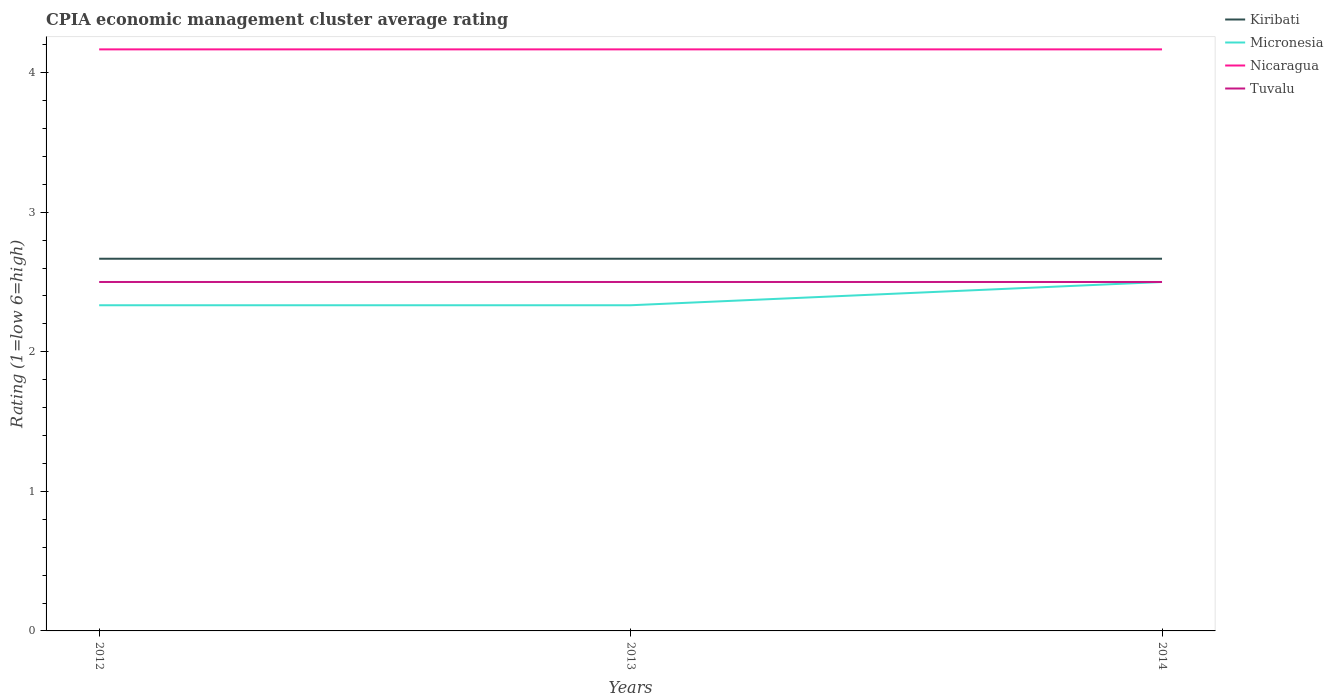Does the line corresponding to Nicaragua intersect with the line corresponding to Kiribati?
Give a very brief answer. No. Is the number of lines equal to the number of legend labels?
Keep it short and to the point. Yes. Across all years, what is the maximum CPIA rating in Micronesia?
Your response must be concise. 2.33. In which year was the CPIA rating in Nicaragua maximum?
Offer a terse response. 2012. What is the difference between the highest and the second highest CPIA rating in Kiribati?
Your answer should be very brief. 3.333333329802457e-6. What is the difference between the highest and the lowest CPIA rating in Tuvalu?
Provide a short and direct response. 0. Is the CPIA rating in Micronesia strictly greater than the CPIA rating in Tuvalu over the years?
Offer a terse response. No. How many years are there in the graph?
Provide a short and direct response. 3. What is the difference between two consecutive major ticks on the Y-axis?
Ensure brevity in your answer.  1. Are the values on the major ticks of Y-axis written in scientific E-notation?
Your answer should be very brief. No. Does the graph contain any zero values?
Make the answer very short. No. How are the legend labels stacked?
Your answer should be very brief. Vertical. What is the title of the graph?
Keep it short and to the point. CPIA economic management cluster average rating. Does "Qatar" appear as one of the legend labels in the graph?
Make the answer very short. No. What is the label or title of the X-axis?
Your answer should be compact. Years. What is the label or title of the Y-axis?
Provide a short and direct response. Rating (1=low 6=high). What is the Rating (1=low 6=high) of Kiribati in 2012?
Your answer should be compact. 2.67. What is the Rating (1=low 6=high) of Micronesia in 2012?
Ensure brevity in your answer.  2.33. What is the Rating (1=low 6=high) in Nicaragua in 2012?
Provide a succinct answer. 4.17. What is the Rating (1=low 6=high) of Tuvalu in 2012?
Offer a terse response. 2.5. What is the Rating (1=low 6=high) in Kiribati in 2013?
Give a very brief answer. 2.67. What is the Rating (1=low 6=high) in Micronesia in 2013?
Offer a very short reply. 2.33. What is the Rating (1=low 6=high) in Nicaragua in 2013?
Offer a terse response. 4.17. What is the Rating (1=low 6=high) of Tuvalu in 2013?
Your response must be concise. 2.5. What is the Rating (1=low 6=high) of Kiribati in 2014?
Make the answer very short. 2.67. What is the Rating (1=low 6=high) in Micronesia in 2014?
Provide a succinct answer. 2.5. What is the Rating (1=low 6=high) of Nicaragua in 2014?
Keep it short and to the point. 4.17. Across all years, what is the maximum Rating (1=low 6=high) in Kiribati?
Your response must be concise. 2.67. Across all years, what is the maximum Rating (1=low 6=high) in Micronesia?
Provide a succinct answer. 2.5. Across all years, what is the maximum Rating (1=low 6=high) in Nicaragua?
Provide a short and direct response. 4.17. Across all years, what is the maximum Rating (1=low 6=high) of Tuvalu?
Give a very brief answer. 2.5. Across all years, what is the minimum Rating (1=low 6=high) in Kiribati?
Your answer should be very brief. 2.67. Across all years, what is the minimum Rating (1=low 6=high) in Micronesia?
Your answer should be compact. 2.33. Across all years, what is the minimum Rating (1=low 6=high) in Nicaragua?
Your answer should be very brief. 4.17. What is the total Rating (1=low 6=high) in Micronesia in the graph?
Keep it short and to the point. 7.17. What is the total Rating (1=low 6=high) in Nicaragua in the graph?
Offer a very short reply. 12.5. What is the total Rating (1=low 6=high) in Tuvalu in the graph?
Your response must be concise. 7.5. What is the difference between the Rating (1=low 6=high) of Kiribati in 2012 and that in 2013?
Your answer should be compact. 0. What is the difference between the Rating (1=low 6=high) in Micronesia in 2012 and that in 2013?
Your response must be concise. 0. What is the difference between the Rating (1=low 6=high) in Nicaragua in 2012 and that in 2013?
Provide a succinct answer. 0. What is the difference between the Rating (1=low 6=high) of Micronesia in 2012 and that in 2014?
Give a very brief answer. -0.17. What is the difference between the Rating (1=low 6=high) of Tuvalu in 2012 and that in 2014?
Your answer should be very brief. 0. What is the difference between the Rating (1=low 6=high) in Micronesia in 2013 and that in 2014?
Provide a succinct answer. -0.17. What is the difference between the Rating (1=low 6=high) in Nicaragua in 2013 and that in 2014?
Make the answer very short. -0. What is the difference between the Rating (1=low 6=high) of Tuvalu in 2013 and that in 2014?
Provide a succinct answer. 0. What is the difference between the Rating (1=low 6=high) in Kiribati in 2012 and the Rating (1=low 6=high) in Nicaragua in 2013?
Offer a very short reply. -1.5. What is the difference between the Rating (1=low 6=high) of Kiribati in 2012 and the Rating (1=low 6=high) of Tuvalu in 2013?
Offer a very short reply. 0.17. What is the difference between the Rating (1=low 6=high) in Micronesia in 2012 and the Rating (1=low 6=high) in Nicaragua in 2013?
Offer a very short reply. -1.83. What is the difference between the Rating (1=low 6=high) in Micronesia in 2012 and the Rating (1=low 6=high) in Tuvalu in 2013?
Your answer should be very brief. -0.17. What is the difference between the Rating (1=low 6=high) of Nicaragua in 2012 and the Rating (1=low 6=high) of Tuvalu in 2013?
Provide a short and direct response. 1.67. What is the difference between the Rating (1=low 6=high) in Kiribati in 2012 and the Rating (1=low 6=high) in Micronesia in 2014?
Provide a succinct answer. 0.17. What is the difference between the Rating (1=low 6=high) of Kiribati in 2012 and the Rating (1=low 6=high) of Nicaragua in 2014?
Your response must be concise. -1.5. What is the difference between the Rating (1=low 6=high) of Kiribati in 2012 and the Rating (1=low 6=high) of Tuvalu in 2014?
Give a very brief answer. 0.17. What is the difference between the Rating (1=low 6=high) of Micronesia in 2012 and the Rating (1=low 6=high) of Nicaragua in 2014?
Offer a very short reply. -1.83. What is the difference between the Rating (1=low 6=high) in Kiribati in 2013 and the Rating (1=low 6=high) in Micronesia in 2014?
Make the answer very short. 0.17. What is the difference between the Rating (1=low 6=high) of Kiribati in 2013 and the Rating (1=low 6=high) of Nicaragua in 2014?
Offer a terse response. -1.5. What is the difference between the Rating (1=low 6=high) in Micronesia in 2013 and the Rating (1=low 6=high) in Nicaragua in 2014?
Your answer should be very brief. -1.83. What is the difference between the Rating (1=low 6=high) in Nicaragua in 2013 and the Rating (1=low 6=high) in Tuvalu in 2014?
Give a very brief answer. 1.67. What is the average Rating (1=low 6=high) in Kiribati per year?
Offer a terse response. 2.67. What is the average Rating (1=low 6=high) of Micronesia per year?
Offer a very short reply. 2.39. What is the average Rating (1=low 6=high) in Nicaragua per year?
Your response must be concise. 4.17. In the year 2012, what is the difference between the Rating (1=low 6=high) in Kiribati and Rating (1=low 6=high) in Tuvalu?
Make the answer very short. 0.17. In the year 2012, what is the difference between the Rating (1=low 6=high) of Micronesia and Rating (1=low 6=high) of Nicaragua?
Provide a succinct answer. -1.83. In the year 2012, what is the difference between the Rating (1=low 6=high) in Micronesia and Rating (1=low 6=high) in Tuvalu?
Offer a very short reply. -0.17. In the year 2013, what is the difference between the Rating (1=low 6=high) in Micronesia and Rating (1=low 6=high) in Nicaragua?
Make the answer very short. -1.83. In the year 2013, what is the difference between the Rating (1=low 6=high) in Nicaragua and Rating (1=low 6=high) in Tuvalu?
Offer a terse response. 1.67. In the year 2014, what is the difference between the Rating (1=low 6=high) of Kiribati and Rating (1=low 6=high) of Micronesia?
Make the answer very short. 0.17. In the year 2014, what is the difference between the Rating (1=low 6=high) in Kiribati and Rating (1=low 6=high) in Nicaragua?
Give a very brief answer. -1.5. In the year 2014, what is the difference between the Rating (1=low 6=high) in Kiribati and Rating (1=low 6=high) in Tuvalu?
Make the answer very short. 0.17. In the year 2014, what is the difference between the Rating (1=low 6=high) in Micronesia and Rating (1=low 6=high) in Nicaragua?
Your answer should be very brief. -1.67. In the year 2014, what is the difference between the Rating (1=low 6=high) of Micronesia and Rating (1=low 6=high) of Tuvalu?
Keep it short and to the point. 0. In the year 2014, what is the difference between the Rating (1=low 6=high) of Nicaragua and Rating (1=low 6=high) of Tuvalu?
Offer a very short reply. 1.67. What is the ratio of the Rating (1=low 6=high) of Micronesia in 2012 to that in 2013?
Offer a terse response. 1. What is the ratio of the Rating (1=low 6=high) in Tuvalu in 2012 to that in 2013?
Ensure brevity in your answer.  1. What is the ratio of the Rating (1=low 6=high) of Kiribati in 2012 to that in 2014?
Provide a succinct answer. 1. What is the ratio of the Rating (1=low 6=high) of Kiribati in 2013 to that in 2014?
Provide a succinct answer. 1. What is the ratio of the Rating (1=low 6=high) of Tuvalu in 2013 to that in 2014?
Offer a terse response. 1. What is the difference between the highest and the second highest Rating (1=low 6=high) in Micronesia?
Provide a short and direct response. 0.17. What is the difference between the highest and the second highest Rating (1=low 6=high) in Tuvalu?
Your response must be concise. 0. What is the difference between the highest and the lowest Rating (1=low 6=high) in Micronesia?
Provide a short and direct response. 0.17. 